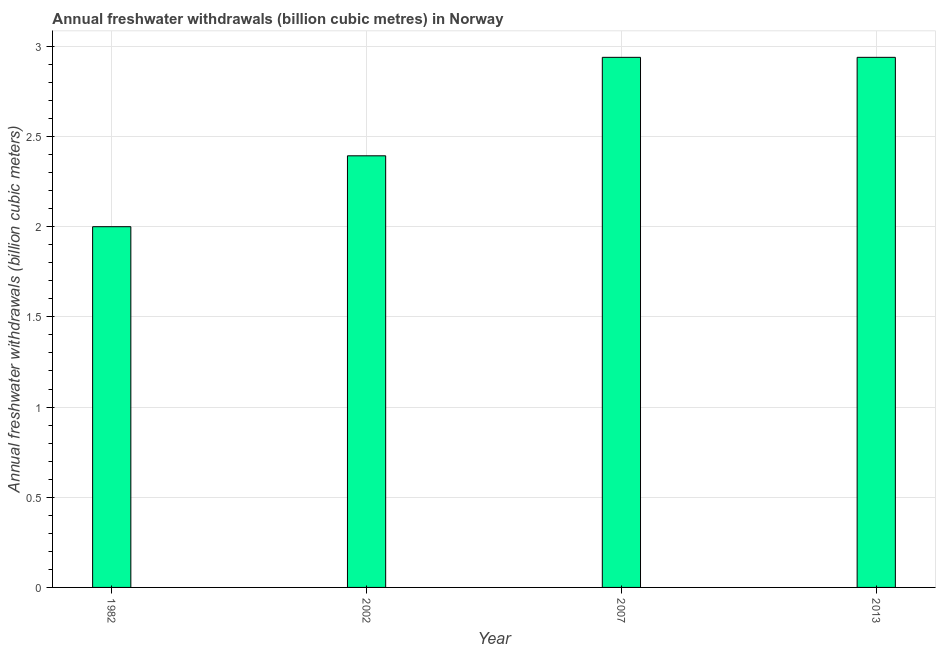Does the graph contain any zero values?
Provide a short and direct response. No. Does the graph contain grids?
Your response must be concise. Yes. What is the title of the graph?
Provide a succinct answer. Annual freshwater withdrawals (billion cubic metres) in Norway. What is the label or title of the X-axis?
Make the answer very short. Year. What is the label or title of the Y-axis?
Make the answer very short. Annual freshwater withdrawals (billion cubic meters). What is the annual freshwater withdrawals in 2013?
Keep it short and to the point. 2.94. Across all years, what is the maximum annual freshwater withdrawals?
Your response must be concise. 2.94. In which year was the annual freshwater withdrawals maximum?
Make the answer very short. 2007. In which year was the annual freshwater withdrawals minimum?
Your answer should be compact. 1982. What is the sum of the annual freshwater withdrawals?
Keep it short and to the point. 10.27. What is the difference between the annual freshwater withdrawals in 1982 and 2002?
Make the answer very short. -0.39. What is the average annual freshwater withdrawals per year?
Provide a short and direct response. 2.57. What is the median annual freshwater withdrawals?
Provide a succinct answer. 2.67. Do a majority of the years between 2002 and 2007 (inclusive) have annual freshwater withdrawals greater than 0.2 billion cubic meters?
Your response must be concise. Yes. What is the ratio of the annual freshwater withdrawals in 1982 to that in 2002?
Keep it short and to the point. 0.84. Is the difference between the annual freshwater withdrawals in 2007 and 2013 greater than the difference between any two years?
Offer a very short reply. No. What is the difference between the highest and the second highest annual freshwater withdrawals?
Provide a short and direct response. 0. Are all the bars in the graph horizontal?
Keep it short and to the point. No. How many years are there in the graph?
Your response must be concise. 4. Are the values on the major ticks of Y-axis written in scientific E-notation?
Provide a succinct answer. No. What is the Annual freshwater withdrawals (billion cubic meters) of 2002?
Provide a succinct answer. 2.39. What is the Annual freshwater withdrawals (billion cubic meters) of 2007?
Provide a short and direct response. 2.94. What is the Annual freshwater withdrawals (billion cubic meters) in 2013?
Provide a succinct answer. 2.94. What is the difference between the Annual freshwater withdrawals (billion cubic meters) in 1982 and 2002?
Your response must be concise. -0.39. What is the difference between the Annual freshwater withdrawals (billion cubic meters) in 1982 and 2007?
Your answer should be compact. -0.94. What is the difference between the Annual freshwater withdrawals (billion cubic meters) in 1982 and 2013?
Your response must be concise. -0.94. What is the difference between the Annual freshwater withdrawals (billion cubic meters) in 2002 and 2007?
Provide a succinct answer. -0.55. What is the difference between the Annual freshwater withdrawals (billion cubic meters) in 2002 and 2013?
Ensure brevity in your answer.  -0.55. What is the ratio of the Annual freshwater withdrawals (billion cubic meters) in 1982 to that in 2002?
Provide a short and direct response. 0.84. What is the ratio of the Annual freshwater withdrawals (billion cubic meters) in 1982 to that in 2007?
Provide a succinct answer. 0.68. What is the ratio of the Annual freshwater withdrawals (billion cubic meters) in 1982 to that in 2013?
Make the answer very short. 0.68. What is the ratio of the Annual freshwater withdrawals (billion cubic meters) in 2002 to that in 2007?
Offer a very short reply. 0.81. What is the ratio of the Annual freshwater withdrawals (billion cubic meters) in 2002 to that in 2013?
Offer a very short reply. 0.81. 